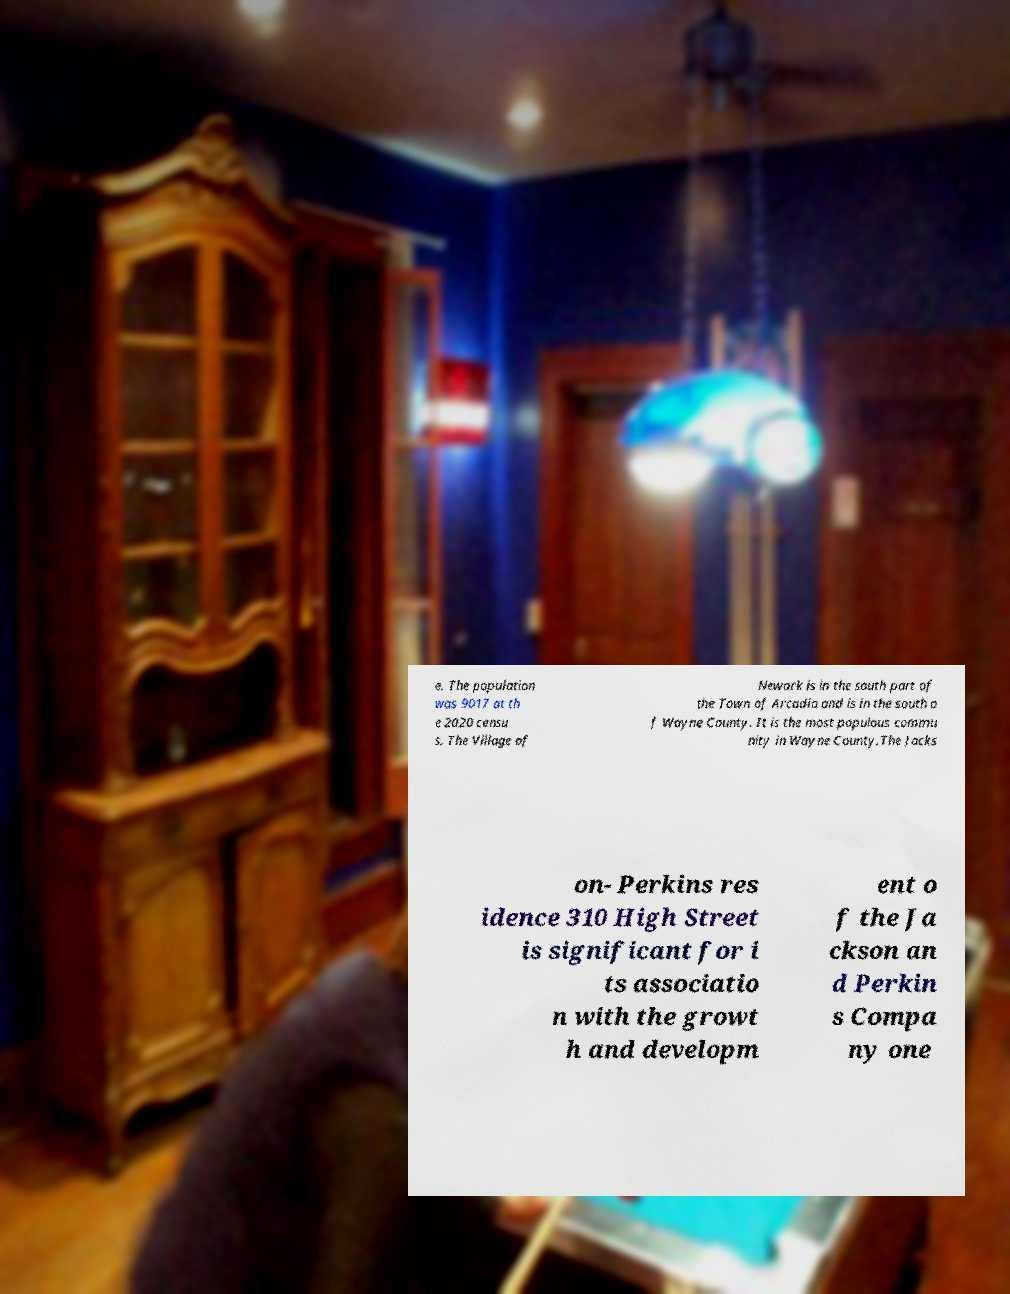For documentation purposes, I need the text within this image transcribed. Could you provide that? e. The population was 9017 at th e 2020 censu s. The Village of Newark is in the south part of the Town of Arcadia and is in the south o f Wayne County. It is the most populous commu nity in Wayne County.The Jacks on- Perkins res idence 310 High Street is significant for i ts associatio n with the growt h and developm ent o f the Ja ckson an d Perkin s Compa ny one 